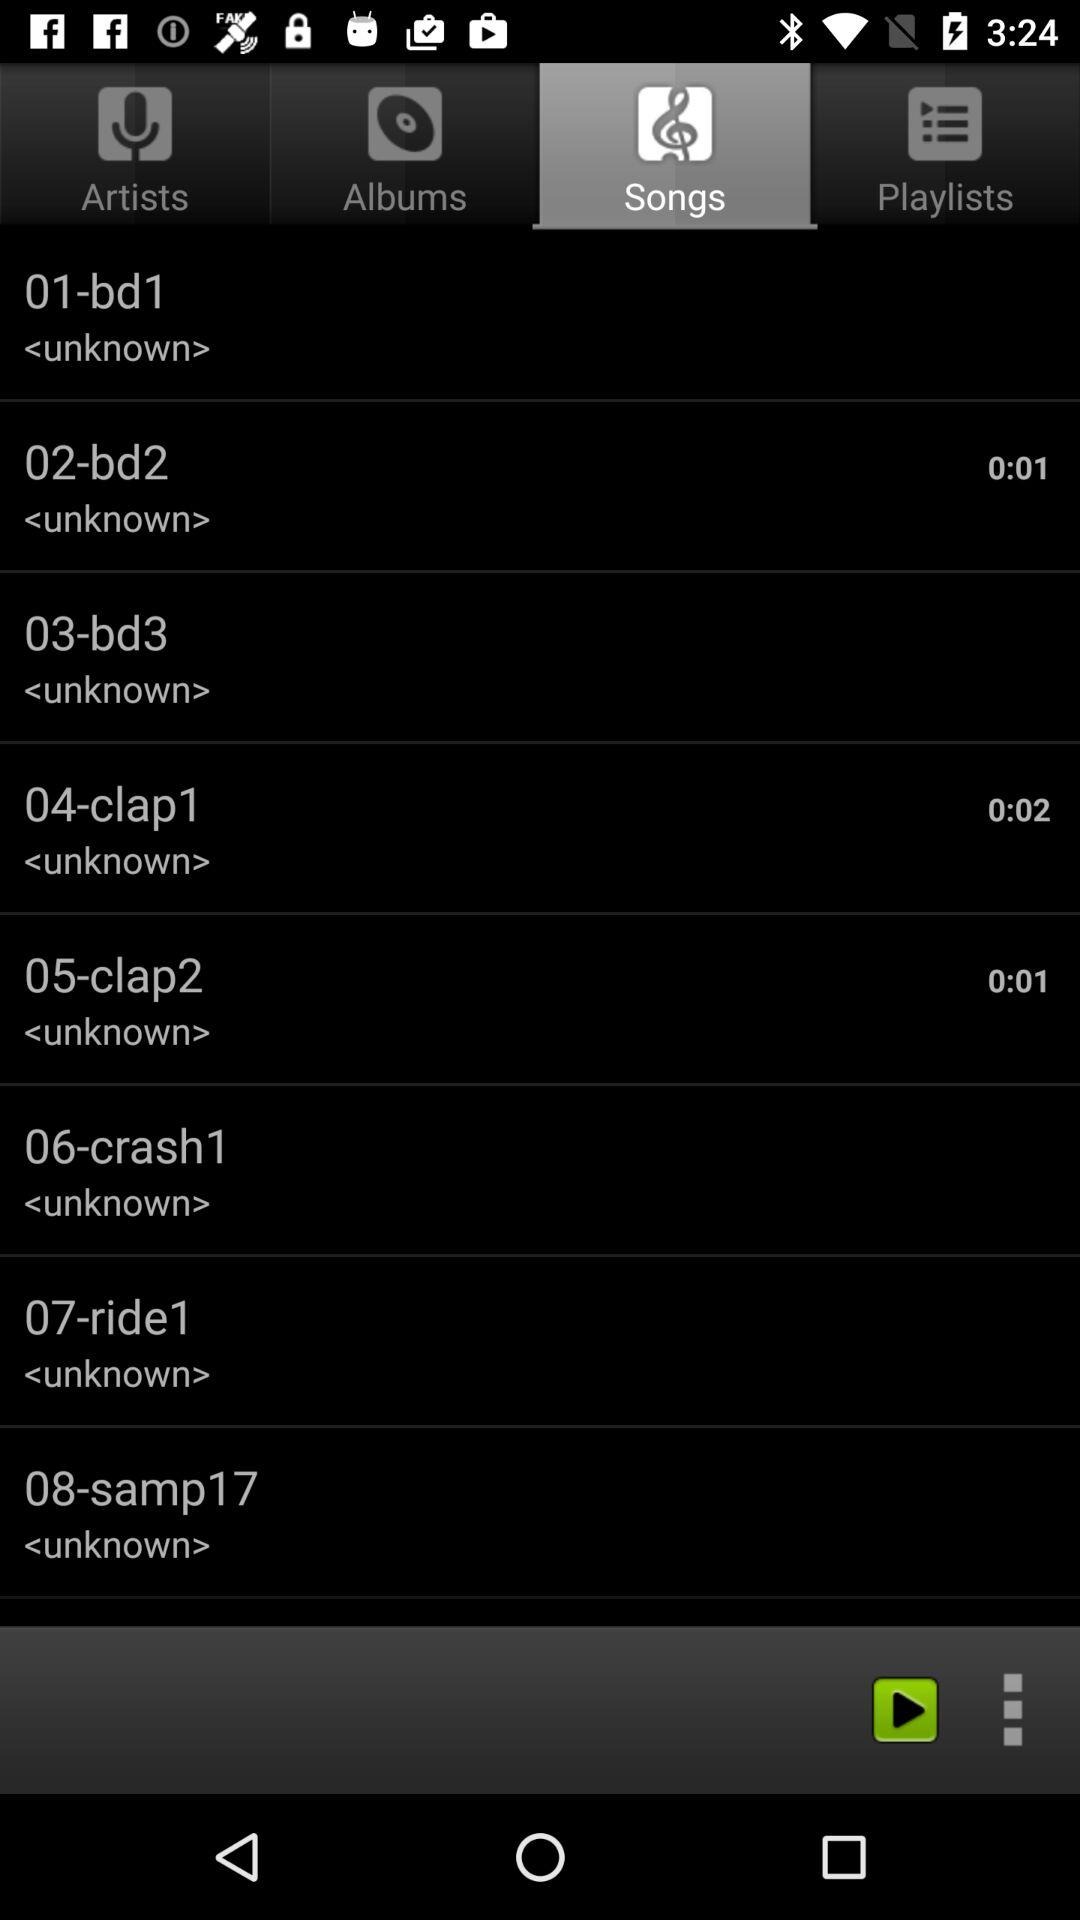What is the duration of the "02-bd2" song? The duration of the "02-bd2" song is 0:01. 